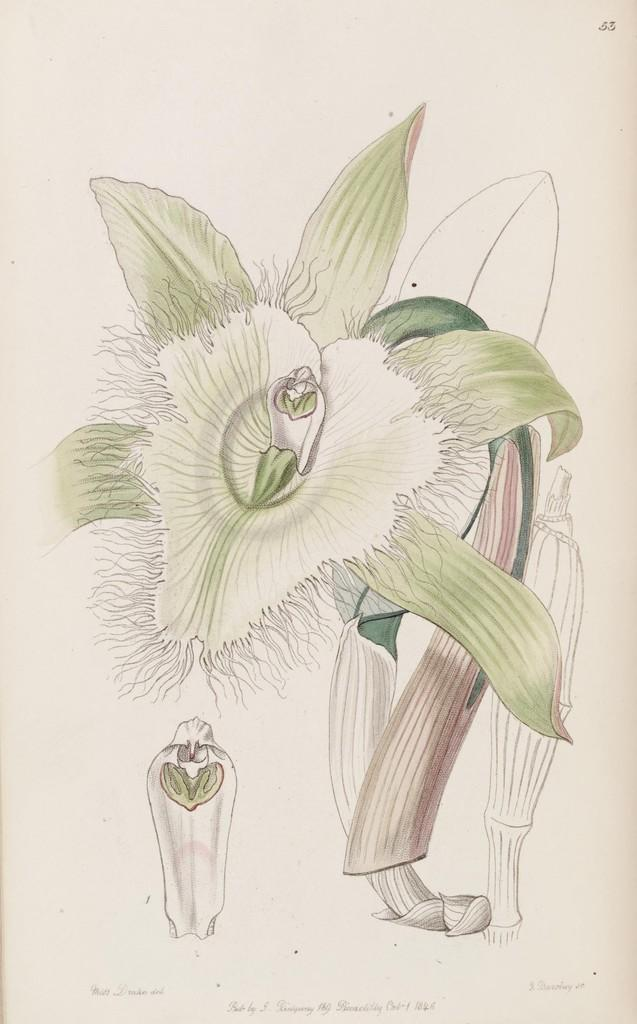What is depicted in the drawing in the image? There is a drawing of a flower in the image. Where is the drawing located? The drawing is on a plant. What stage of growth is the flower in the image? There is a flower bud in the image. What is the color of the paper on which the drawing is made? The paper is cream-colored. What type of goat can be seen grazing near the flower in the image? There is no goat present in the image; it only features a drawing of a flower on a plant. 